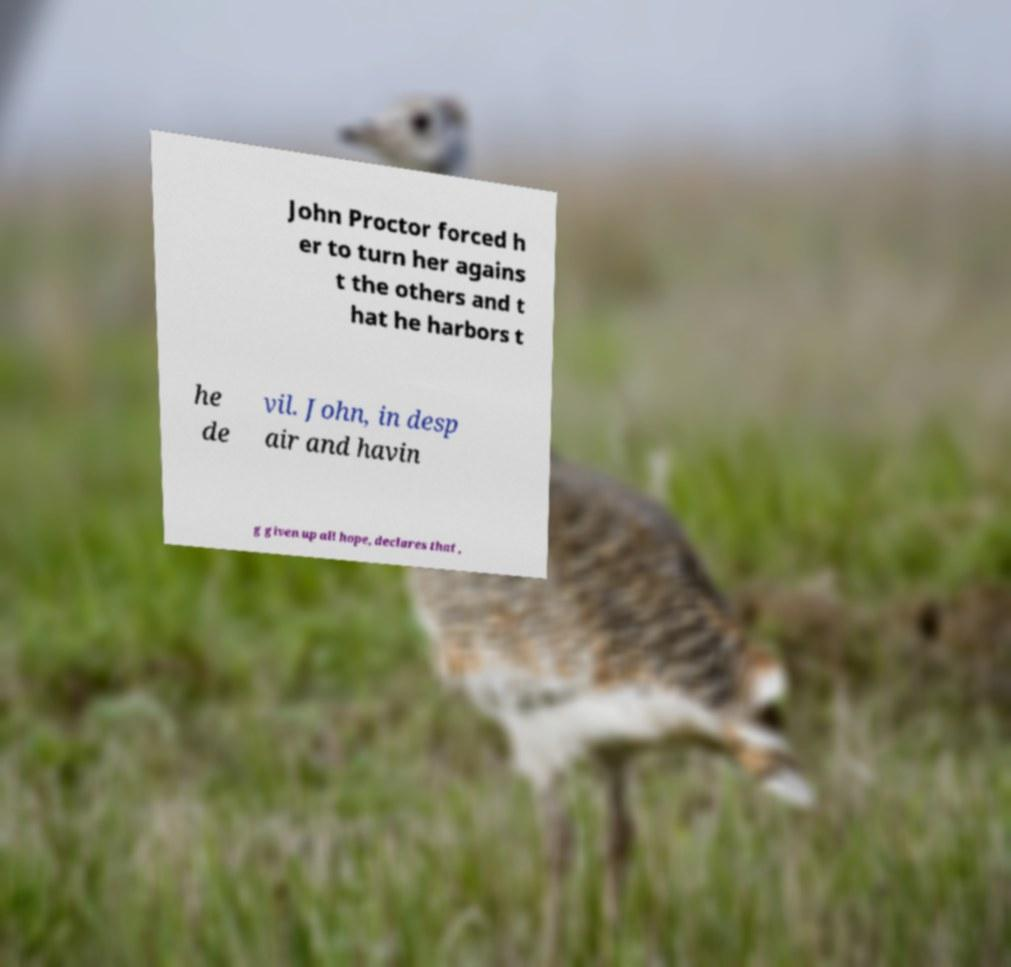There's text embedded in this image that I need extracted. Can you transcribe it verbatim? John Proctor forced h er to turn her agains t the others and t hat he harbors t he de vil. John, in desp air and havin g given up all hope, declares that , 